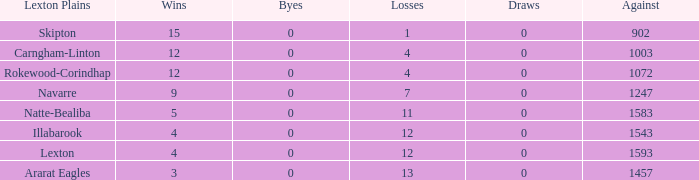Which unit has not more than 8 wins and lesser than 1593 against? Natte-Bealiba, Illabarook, Ararat Eagles. 